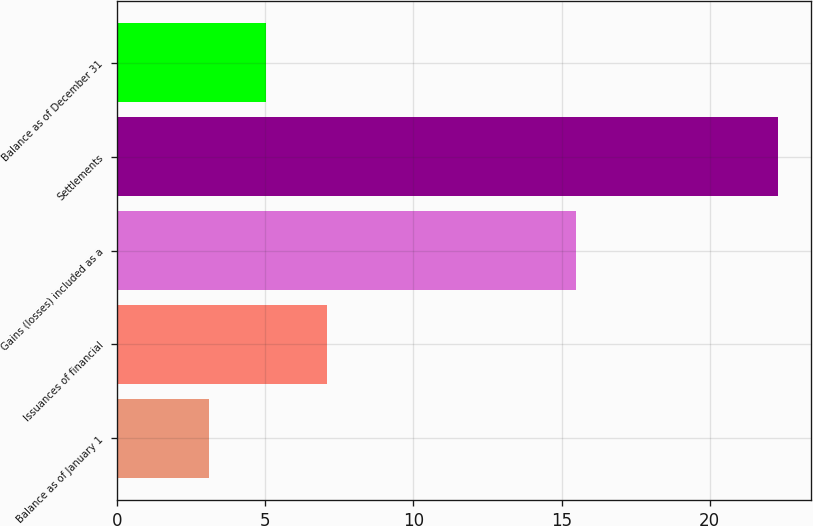<chart> <loc_0><loc_0><loc_500><loc_500><bar_chart><fcel>Balance as of January 1<fcel>Issuances of financial<fcel>Gains (losses) included as a<fcel>Settlements<fcel>Balance as of December 31<nl><fcel>3.1<fcel>7.1<fcel>15.5<fcel>22.3<fcel>5.02<nl></chart> 